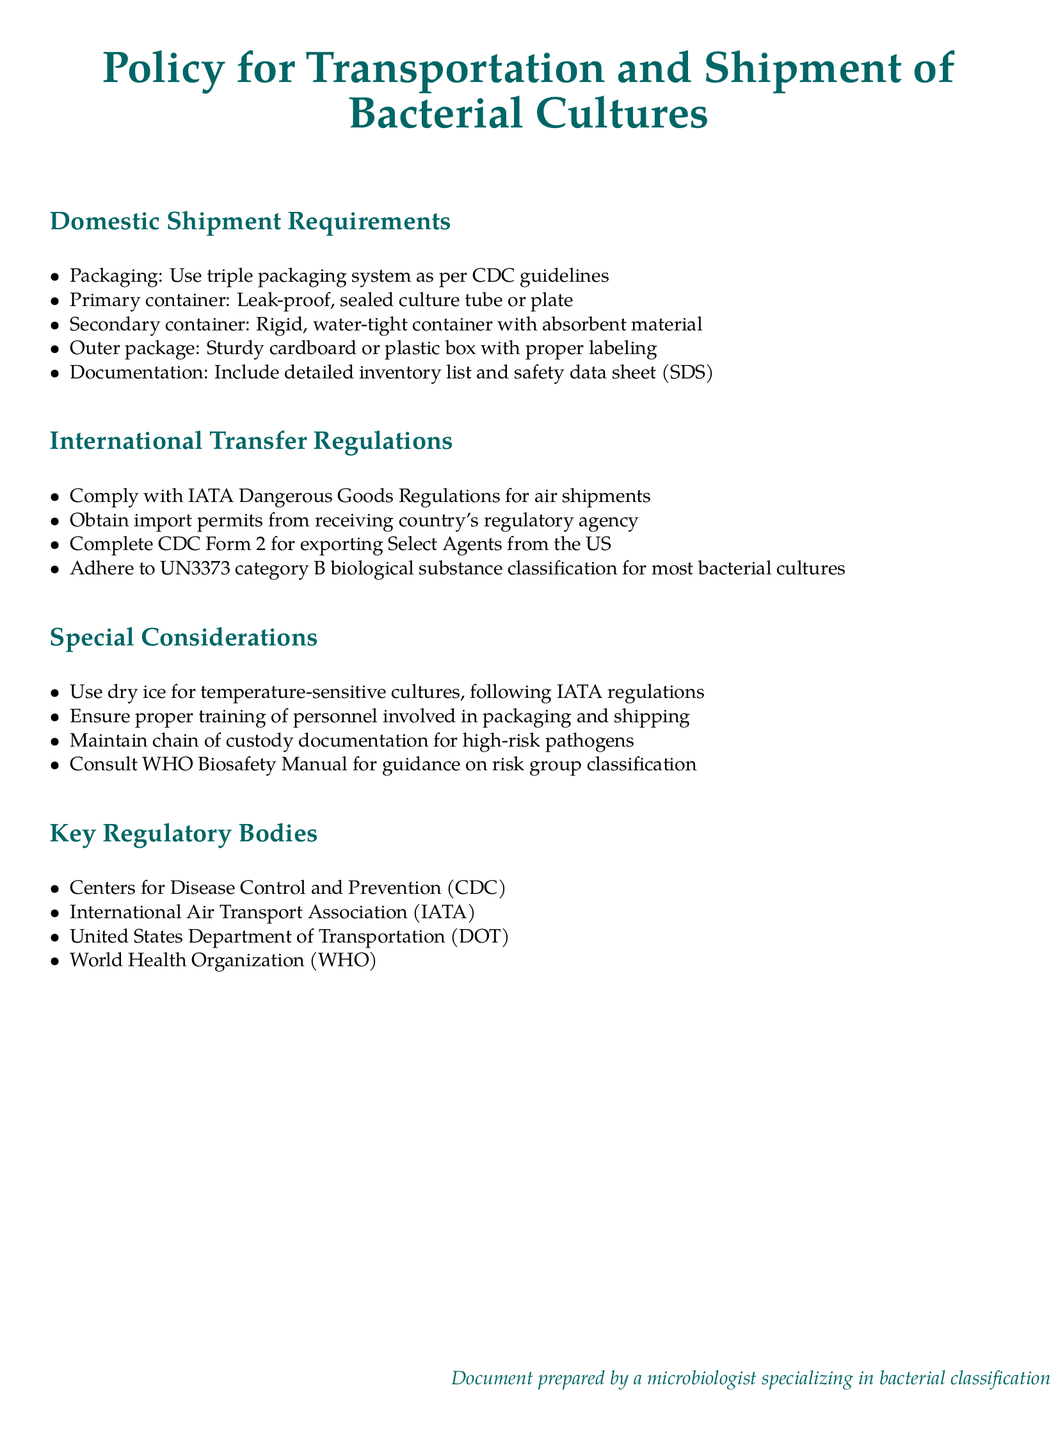What is the primary container requirement for domestic shipments? The primary container must be a leak-proof, sealed culture tube or plate as per the document specifications.
Answer: Leak-proof culture tube or plate What must be included in the documentation for domestic shipments? The document specifies that a detailed inventory list and safety data sheet must be included in the documentation.
Answer: Detailed inventory list and safety data sheet Which regulatory body is responsible for dangerous goods regulations? The document lists the International Air Transport Association (IATA) as responsible for dangerous goods regulations for air shipments.
Answer: International Air Transport Association (IATA) What must be done to ship Select Agents from the US? The document states that CDC Form 2 must be completed for exporting Select Agents.
Answer: Complete CDC Form 2 What should be used for temperature-sensitive cultures? According to the document, dry ice should be used for temperature-sensitive cultures.
Answer: Dry ice What classification is mentioned for most bacterial cultures? The document mentions UN3373 category B biological substance as the classification for most bacterial cultures.
Answer: UN3373 category B biological substance What is the role of the World Health Organization in this context? The World Health Organization is provided as a key regulatory body, indicating its importance in biosafety regulations and guidelines.
Answer: Key regulatory body Who should be trained for packaging and shipping? The document requires that personnel involved in packaging and shipping must be properly trained.
Answer: Personnel involved in packaging and shipping What is one special consideration when shipping high-risk pathogens? The document states that maintaining chain of custody documentation is essential for high-risk pathogens.
Answer: Chain of custody documentation 